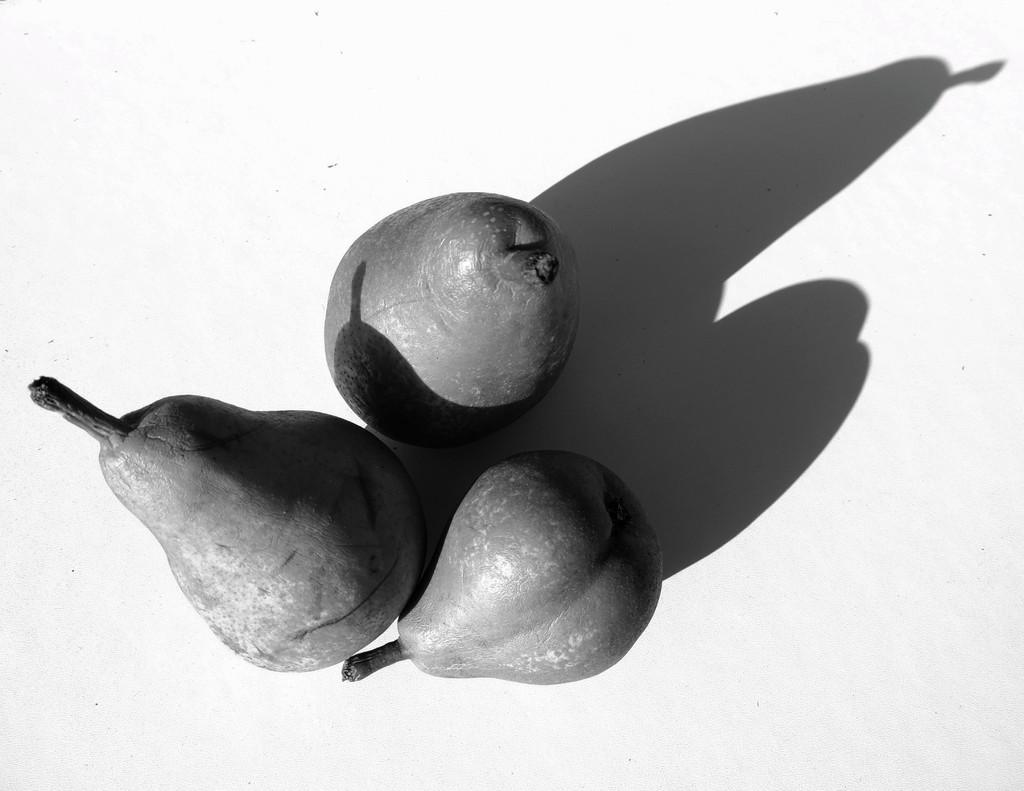What type of fruit is present in the image? There are pears in the image. What other element can be seen in the image besides the pears? There is a shadow in the image. Where are the pears and shadow located in the image? The pears and shadow are on a platform. What type of coast can be seen in the image? There is no coast present in the image; it features pears and a shadow on a platform. How does the stick interact with the pears in the image? There is no stick present in the image; it only features pears and a shadow on a platform. 